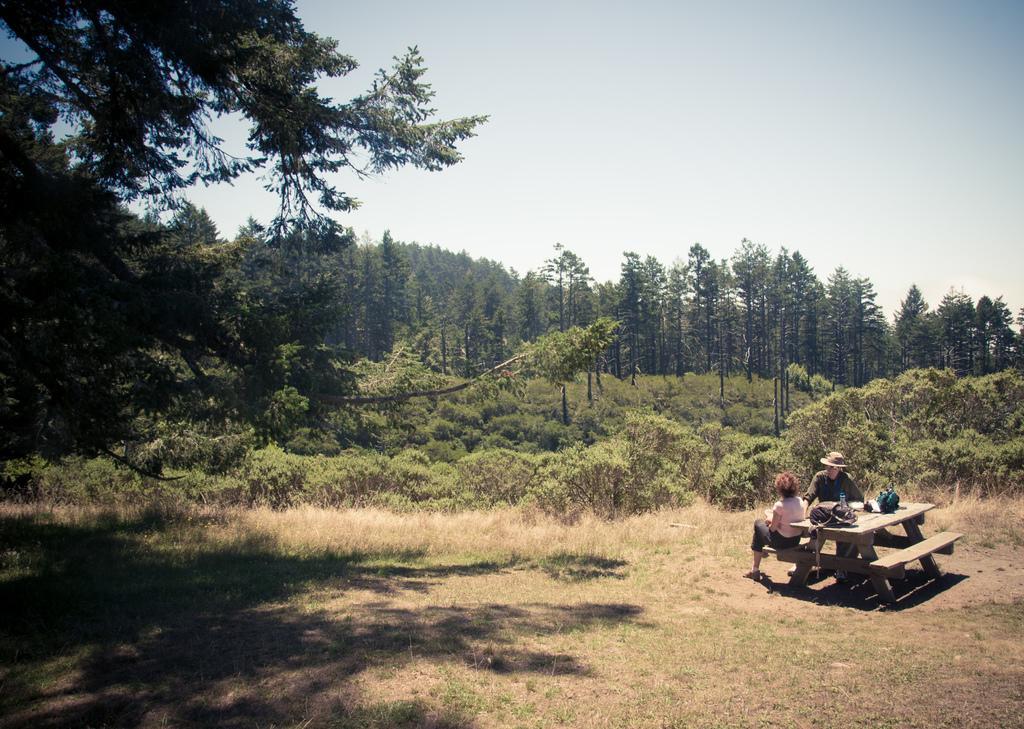Could you give a brief overview of what you see in this image? In this image I can see grass, shadows, bench, number of trees, the sky and here I can see two people. I can see one of them is sitting and one is standing. I can also see few stuffs over here. 